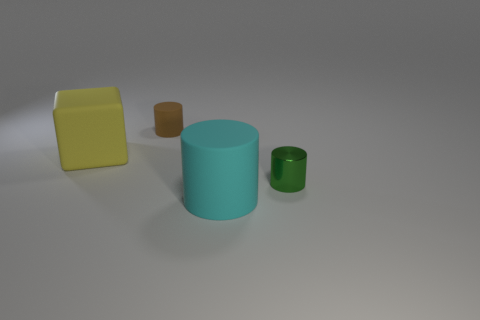Is there any other thing that is the same material as the green cylinder?
Keep it short and to the point. No. There is a cylinder that is right of the big cyan thing; how big is it?
Offer a very short reply. Small. What material is the brown thing that is the same shape as the cyan object?
Provide a short and direct response. Rubber. Are there any other things that have the same size as the brown object?
Give a very brief answer. Yes. The big object that is to the left of the big cyan object has what shape?
Ensure brevity in your answer.  Cube. How many cyan matte things are the same shape as the tiny green metallic thing?
Provide a succinct answer. 1. Are there the same number of green metallic things that are in front of the green shiny object and big yellow things that are in front of the large yellow matte block?
Your answer should be very brief. Yes. Are there any gray blocks made of the same material as the green thing?
Provide a short and direct response. No. Is the cyan cylinder made of the same material as the cube?
Make the answer very short. Yes. How many blue objects are either large rubber cylinders or tiny cylinders?
Keep it short and to the point. 0. 